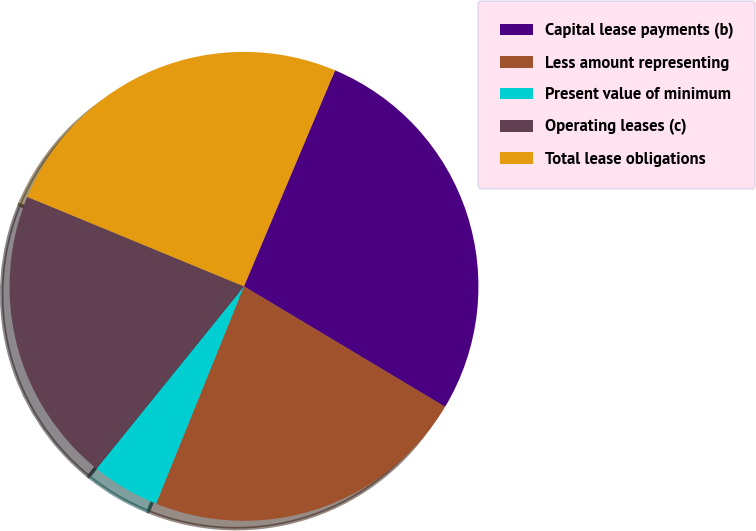<chart> <loc_0><loc_0><loc_500><loc_500><pie_chart><fcel>Capital lease payments (b)<fcel>Less amount representing<fcel>Present value of minimum<fcel>Operating leases (c)<fcel>Total lease obligations<nl><fcel>27.24%<fcel>22.53%<fcel>4.71%<fcel>20.41%<fcel>25.12%<nl></chart> 